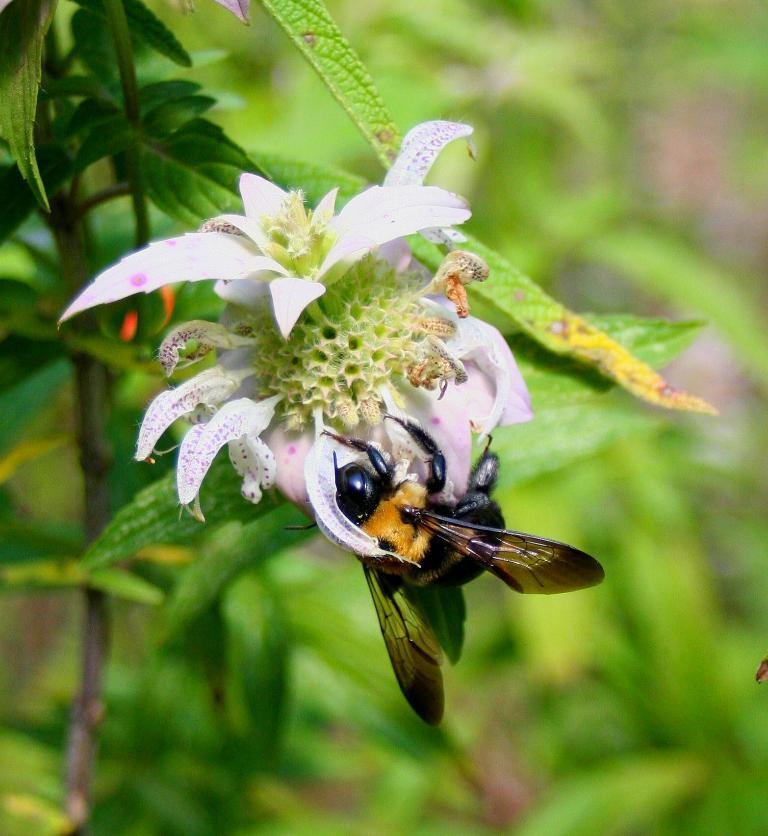What type of insect is present in the image? There is a bee in the image. Where is the bee located in the image? The bee is present on a flower. What is the flower attached to in the image? The flower is on a plant. What type of bottle can be seen in the image? There is no bottle present in the image; it features a bee on a flower. What type of nut is the bee trying to open in the image? There is no nut present in the image; it features a bee on a flower. 